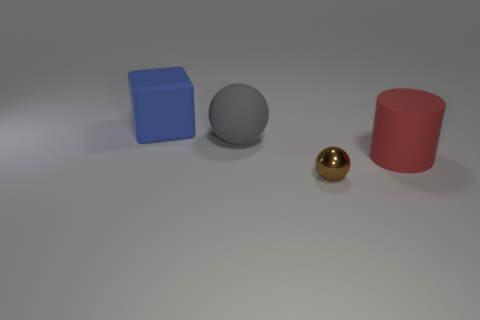Subtract all blocks. How many objects are left? 3 Subtract all green balls. Subtract all blue cubes. How many balls are left? 2 Subtract all purple balls. How many gray cylinders are left? 0 Subtract all brown spheres. Subtract all gray matte things. How many objects are left? 2 Add 3 gray rubber spheres. How many gray rubber spheres are left? 4 Add 4 tiny blue rubber cylinders. How many tiny blue rubber cylinders exist? 4 Add 1 large red rubber cylinders. How many objects exist? 5 Subtract all brown spheres. How many spheres are left? 1 Subtract 0 green spheres. How many objects are left? 4 